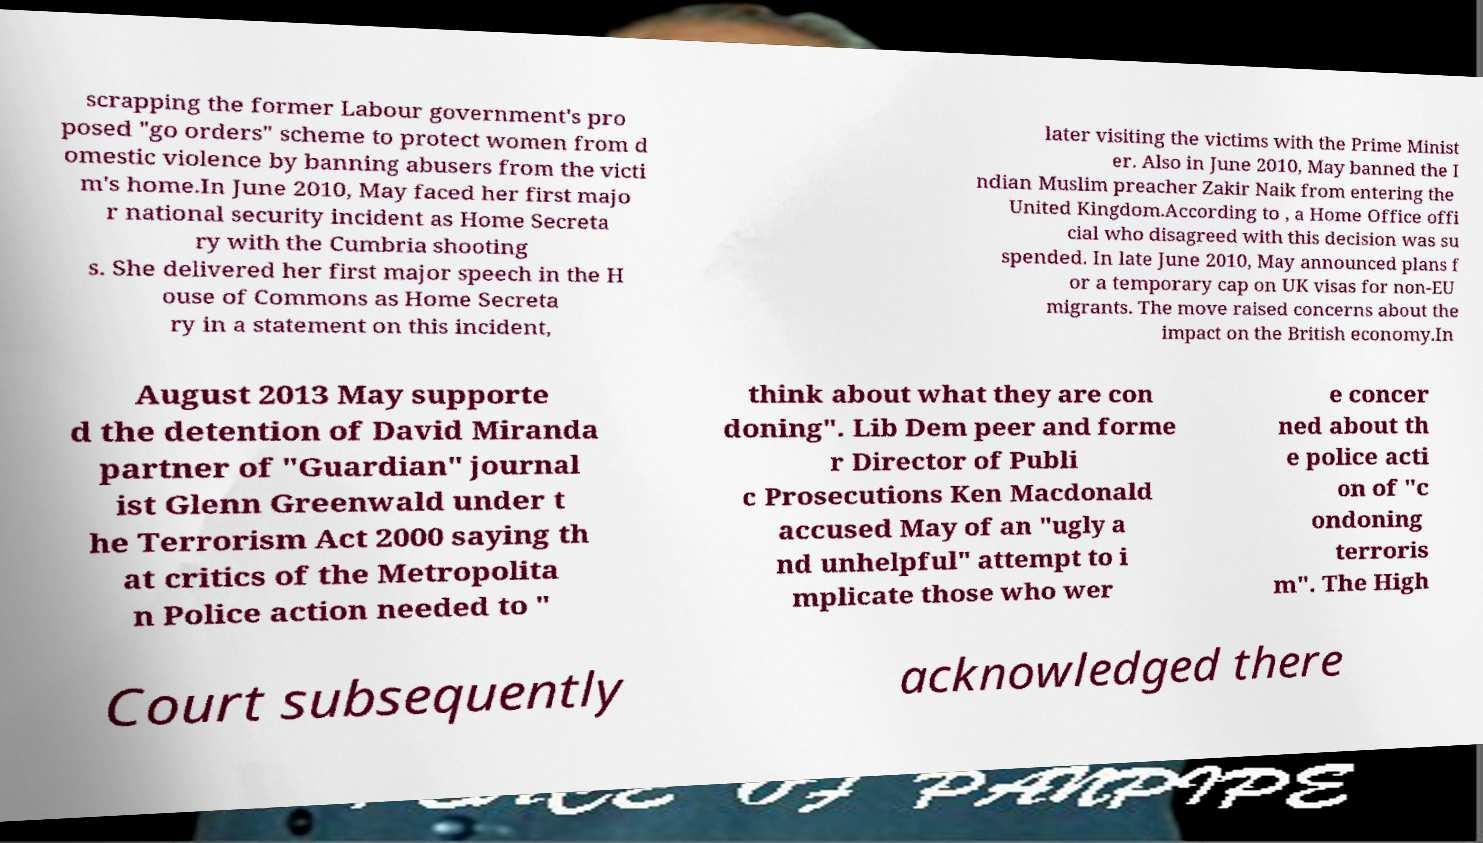What messages or text are displayed in this image? I need them in a readable, typed format. scrapping the former Labour government's pro posed "go orders" scheme to protect women from d omestic violence by banning abusers from the victi m's home.In June 2010, May faced her first majo r national security incident as Home Secreta ry with the Cumbria shooting s. She delivered her first major speech in the H ouse of Commons as Home Secreta ry in a statement on this incident, later visiting the victims with the Prime Minist er. Also in June 2010, May banned the I ndian Muslim preacher Zakir Naik from entering the United Kingdom.According to , a Home Office offi cial who disagreed with this decision was su spended. In late June 2010, May announced plans f or a temporary cap on UK visas for non-EU migrants. The move raised concerns about the impact on the British economy.In August 2013 May supporte d the detention of David Miranda partner of "Guardian" journal ist Glenn Greenwald under t he Terrorism Act 2000 saying th at critics of the Metropolita n Police action needed to " think about what they are con doning". Lib Dem peer and forme r Director of Publi c Prosecutions Ken Macdonald accused May of an "ugly a nd unhelpful" attempt to i mplicate those who wer e concer ned about th e police acti on of "c ondoning terroris m". The High Court subsequently acknowledged there 